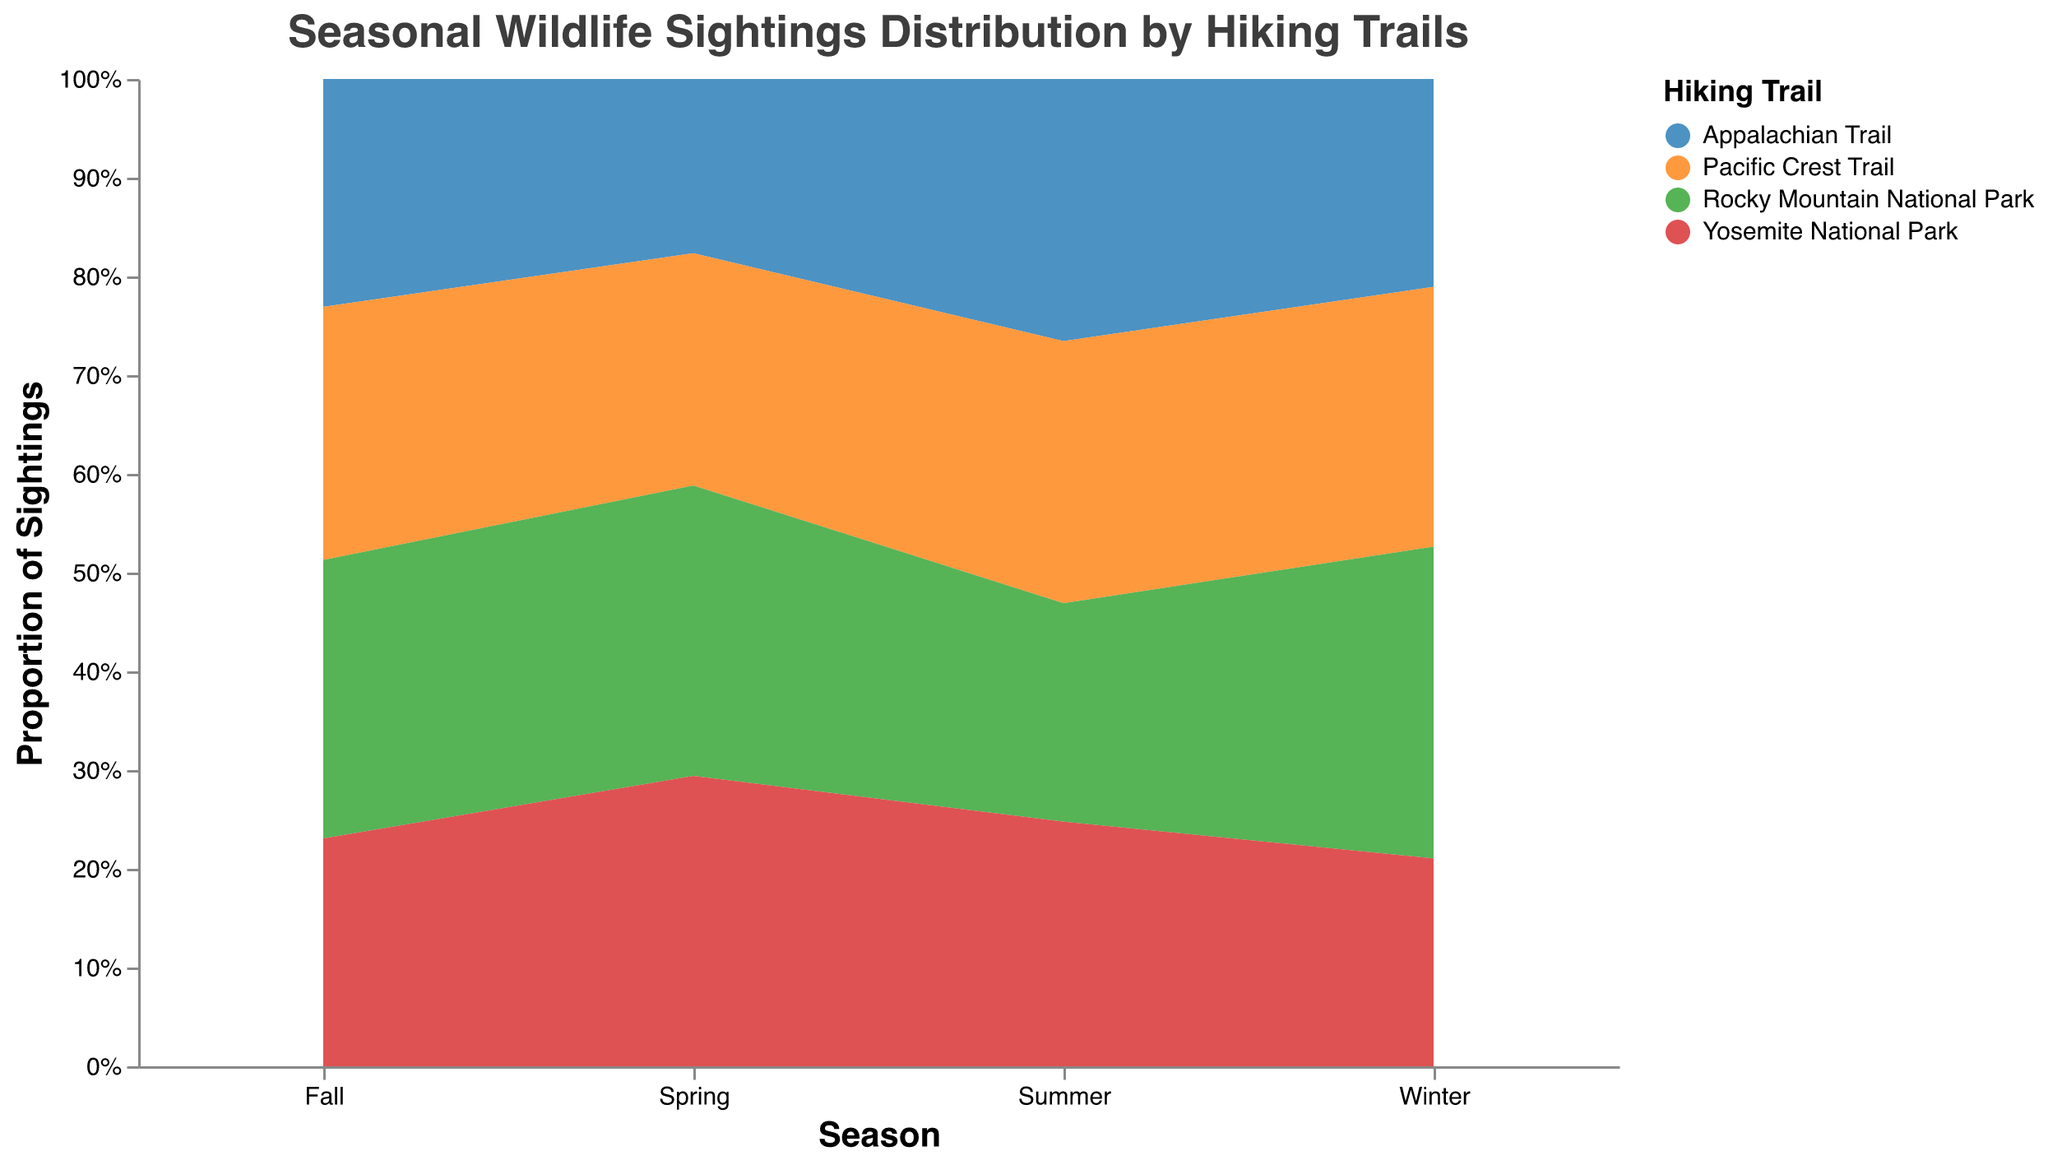What is the title of the figure? The title of the figure is located at the top and it provides an overall description of what the chart is about.
Answer: Seasonal Wildlife Sightings Distribution by Hiking Trails How many trails are compared in the chart? The legend on the right-hand side of the chart shows different colors representing each trail. Count the distinct trail names.
Answer: Four Which animal shows the highest proportion of sightings in the Appalachian Trail during Spring? Review the stack for the Appalachian Trail during Spring and identify the animal group with the largest segment.
Answer: Birds In which season does the Pacific Crest Trail have the lowest proportion of elk sightings? Examine the segments for elk sightings along the Pacific Crest Trail across all seasons to find the season with the smallest segment for % Elk.
Answer: Spring How does the proportion of bird sightings in Yosemite National Park vary between Winter and Summer? Observe the size of the % Bird segments for Yosemite National Park across Winter and Summer. Compare the Winter and Summer segments for % Bird.
Answer: The proportion increases from Winter to Summer Which trail shows the most consistent distribution of animal sightings across all seasons? Observe the variation in the sizes of segments for each trail across all seasons. Determine the trail where the segments are most evenly distributed.
Answer: Rocky Mountain National Park What is the difference in the proportion of deer sightings between Rocky Mountain National Park in Winter and Yosemite National Park in Fall? Calculate the absolute difference between the % Deer in Rocky Mountain National Park during Winter and % Deer in Yosemite National Park during Fall.
Answer: 0.12 In which season are fox sightings most evenly distributed among all four trails? Examine the segments for % Fox across all trails in each season and determine which season has the smallest variation in segment sizes.
Answer: Spring Which trail has the highest proportion of elk sightings in Fall? Look at the Fall season's distribution and identify the trail with the largest segment for % Elk.
Answer: Yosemite National Park How does the proportion of elk sightings on the Appalachian Trail in Winter compare to Summer? Compare the sizes of the % Elk segments for the Appalachian Trail during Winter and Summer. Determine the relationship between the two proportions.
Answer: The proportion in Winter is higher than in Summer 